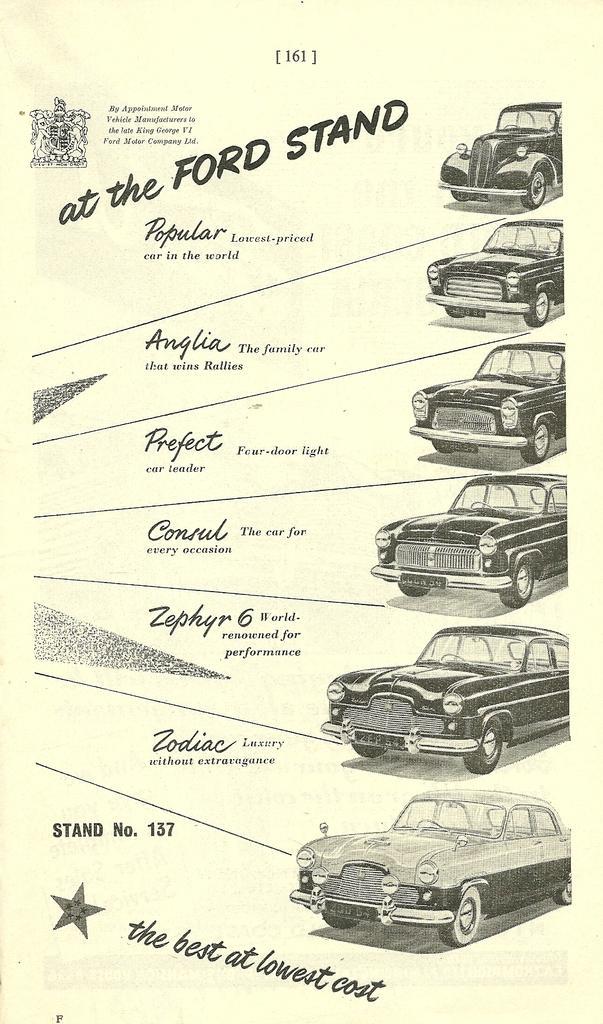In one or two sentences, can you explain what this image depicts? In this picture there are images of few cars which are in black color and there is something written beside it. 